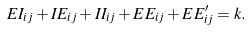<formula> <loc_0><loc_0><loc_500><loc_500>E I _ { i j } + I E _ { i j } + I I _ { i j } + E E _ { i j } + E E ^ { \prime } _ { i j } = k .</formula> 